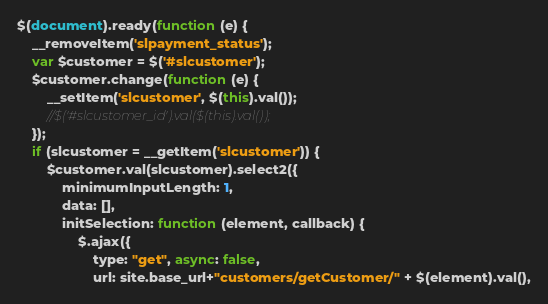Convert code to text. <code><loc_0><loc_0><loc_500><loc_500><_JavaScript_>$(document).ready(function (e) {
	__removeItem('slpayment_status');	
    var $customer = $('#slcustomer');
    $customer.change(function (e) {
        __setItem('slcustomer', $(this).val());
        //$('#slcustomer_id').val($(this).val());
    });
    if (slcustomer = __getItem('slcustomer')) {
        $customer.val(slcustomer).select2({
            minimumInputLength: 1,
            data: [],
            initSelection: function (element, callback) {
                $.ajax({
                    type: "get", async: false,
                    url: site.base_url+"customers/getCustomer/" + $(element).val(),</code> 